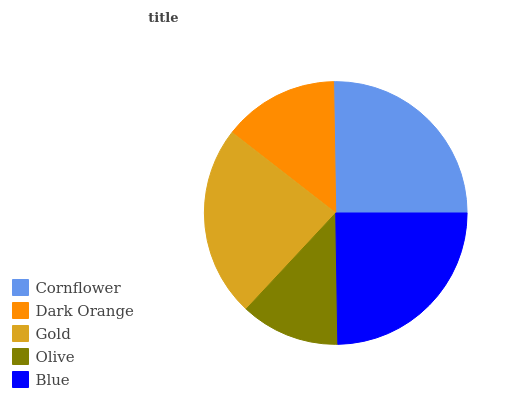Is Olive the minimum?
Answer yes or no. Yes. Is Cornflower the maximum?
Answer yes or no. Yes. Is Dark Orange the minimum?
Answer yes or no. No. Is Dark Orange the maximum?
Answer yes or no. No. Is Cornflower greater than Dark Orange?
Answer yes or no. Yes. Is Dark Orange less than Cornflower?
Answer yes or no. Yes. Is Dark Orange greater than Cornflower?
Answer yes or no. No. Is Cornflower less than Dark Orange?
Answer yes or no. No. Is Gold the high median?
Answer yes or no. Yes. Is Gold the low median?
Answer yes or no. Yes. Is Cornflower the high median?
Answer yes or no. No. Is Dark Orange the low median?
Answer yes or no. No. 